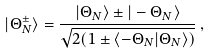Convert formula to latex. <formula><loc_0><loc_0><loc_500><loc_500>| \Theta _ { N } ^ { \pm } \rangle = \frac { | \Theta _ { N } \rangle \pm | - \Theta _ { N } \rangle } { \sqrt { 2 ( 1 \pm \langle - \Theta _ { N } | \Theta _ { N } \rangle ) } } \, ,</formula> 